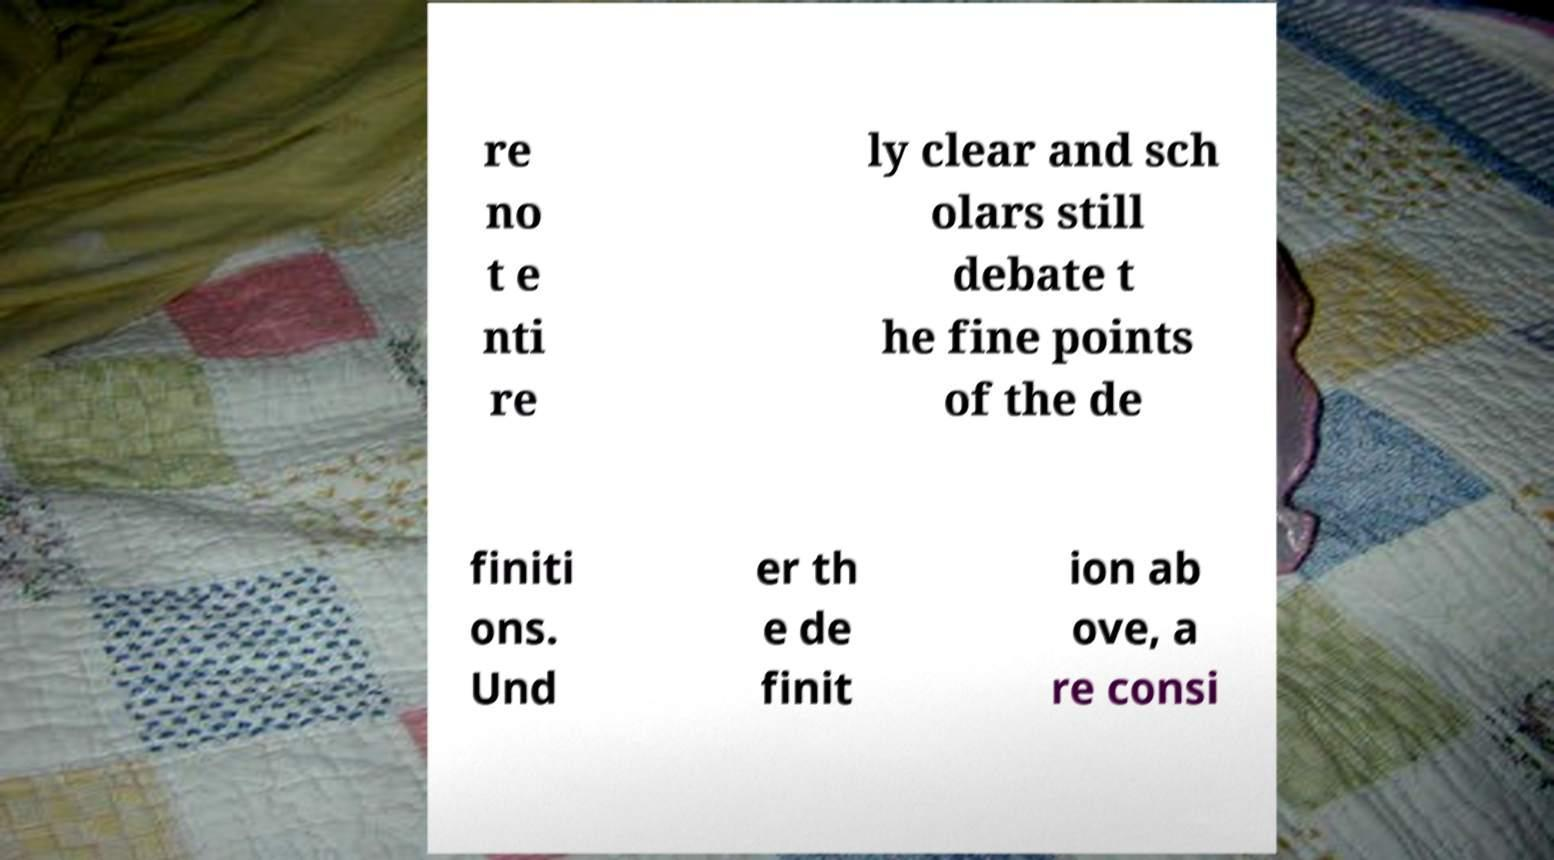I need the written content from this picture converted into text. Can you do that? re no t e nti re ly clear and sch olars still debate t he fine points of the de finiti ons. Und er th e de finit ion ab ove, a re consi 